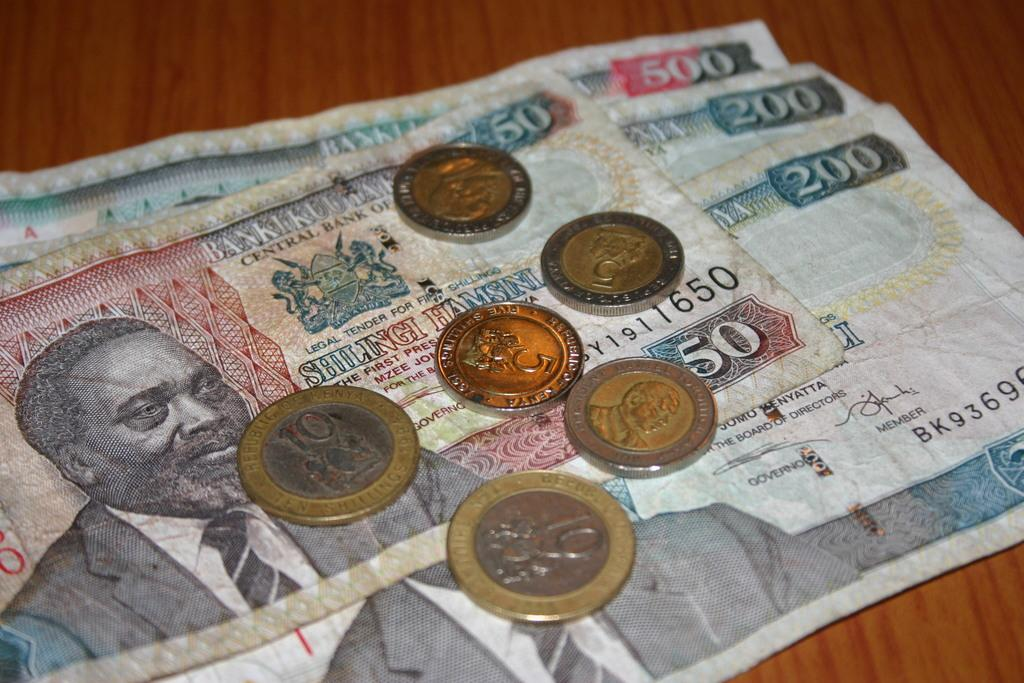Provide a one-sentence caption for the provided image. Paper money in denominations of 50, 200 and 500. 